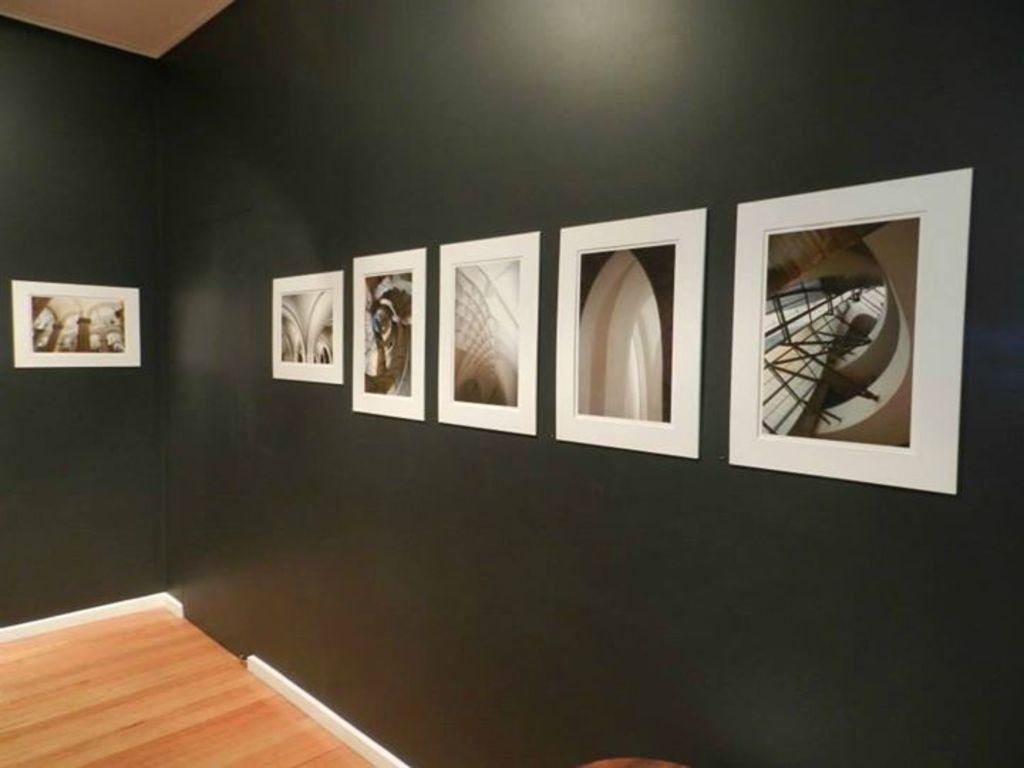What color are the walls in the room? The walls in the room are black. What can be seen hanging on the walls? There are photo frames on the walls. What type of flooring is present in the room? The flooring in the room is wooden. How many times does the person in the room ask a question in the image? There is no person present in the image, so it is not possible to determine how many times they ask a question. 